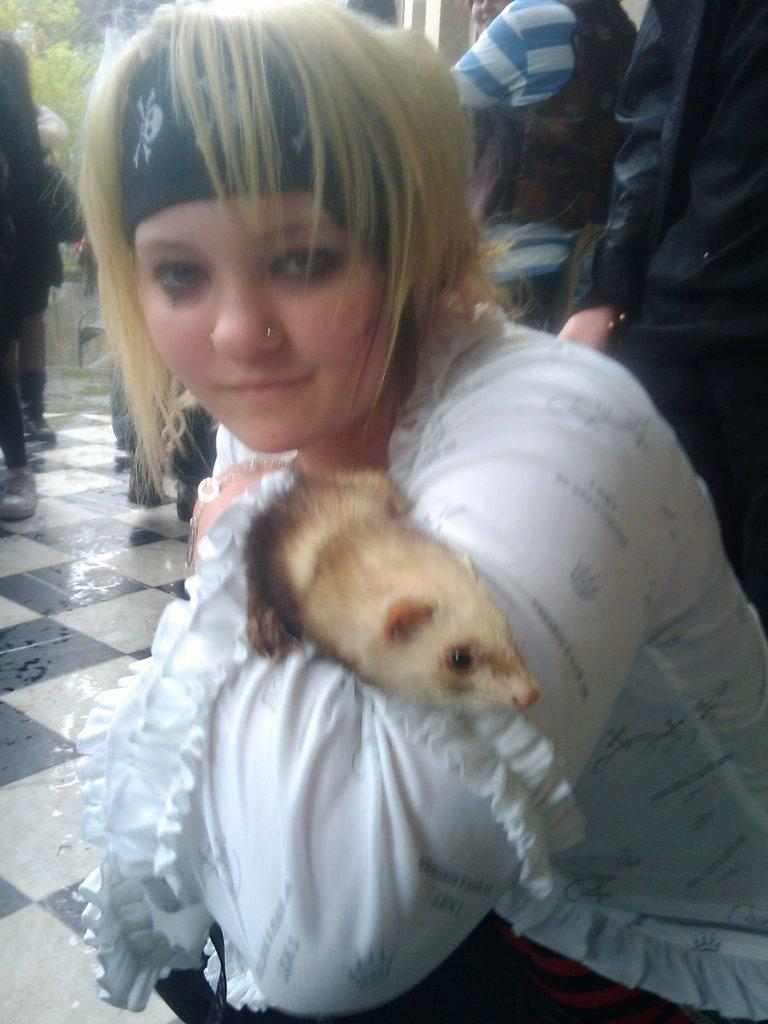What is present in the image that represents a natural element? There is a tree in the image. What are the people in the image doing? The people in the image are standing and sitting. Can you describe the woman's action in the image? The woman is sitting in the image and holding an animal. How many sisters are visible in the image? There is no mention of sisters in the image, so we cannot determine the number of sisters present. What type of cap is the woman wearing in the image? There is no cap mentioned or visible in the image. 